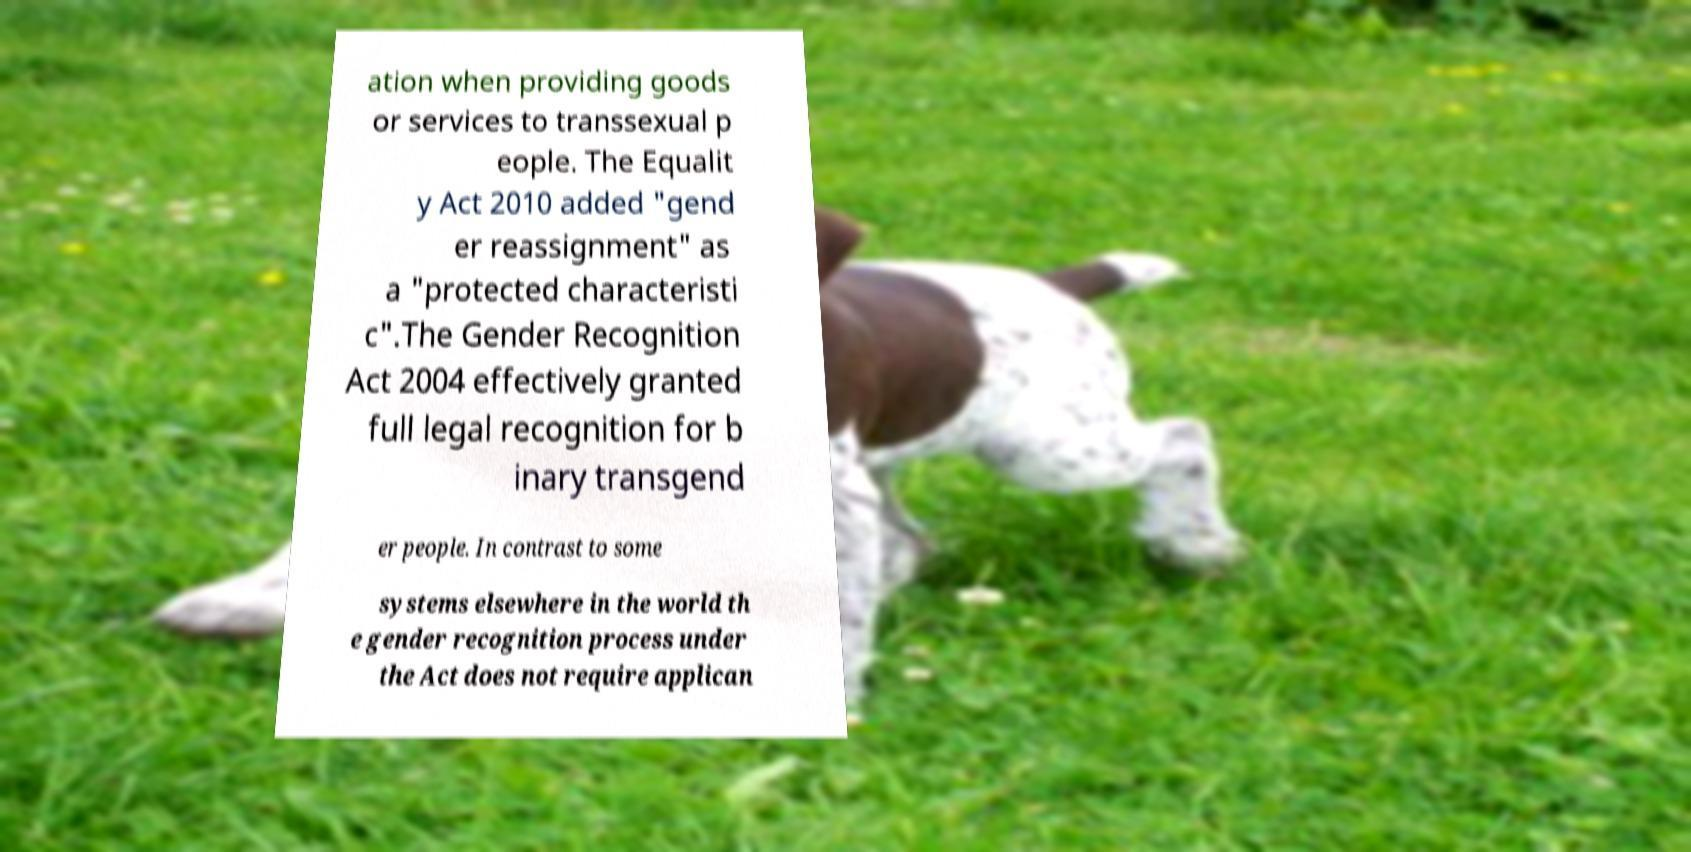What messages or text are displayed in this image? I need them in a readable, typed format. ation when providing goods or services to transsexual p eople. The Equalit y Act 2010 added "gend er reassignment" as a "protected characteristi c".The Gender Recognition Act 2004 effectively granted full legal recognition for b inary transgend er people. In contrast to some systems elsewhere in the world th e gender recognition process under the Act does not require applican 